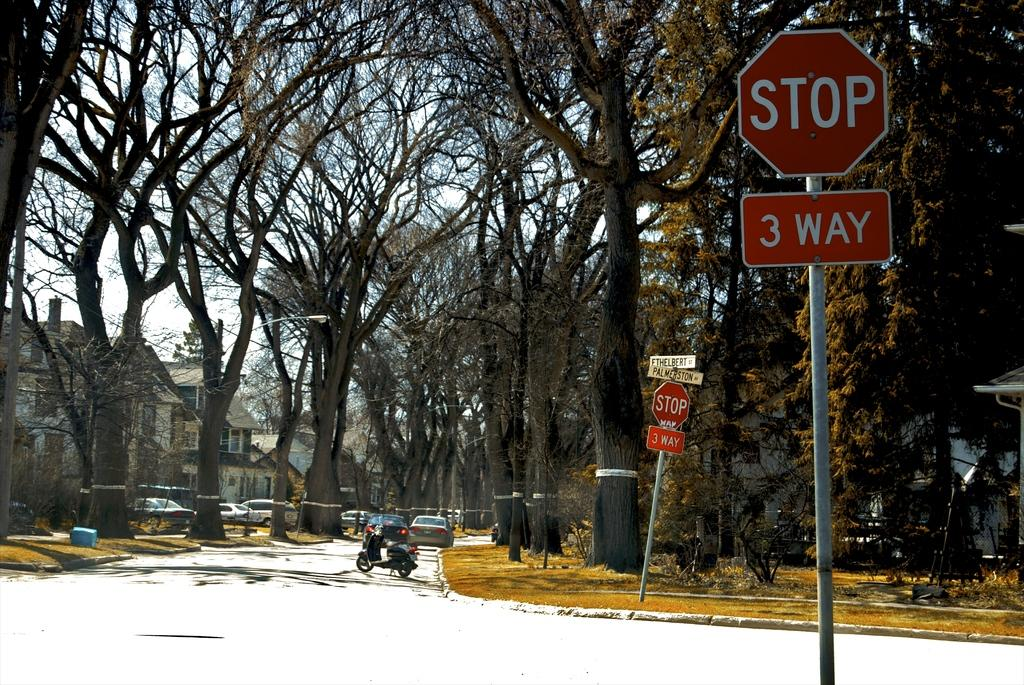<image>
Relay a brief, clear account of the picture shown. A 3 way stop sign stands on the corner of Ethelbert and Palmeston. 